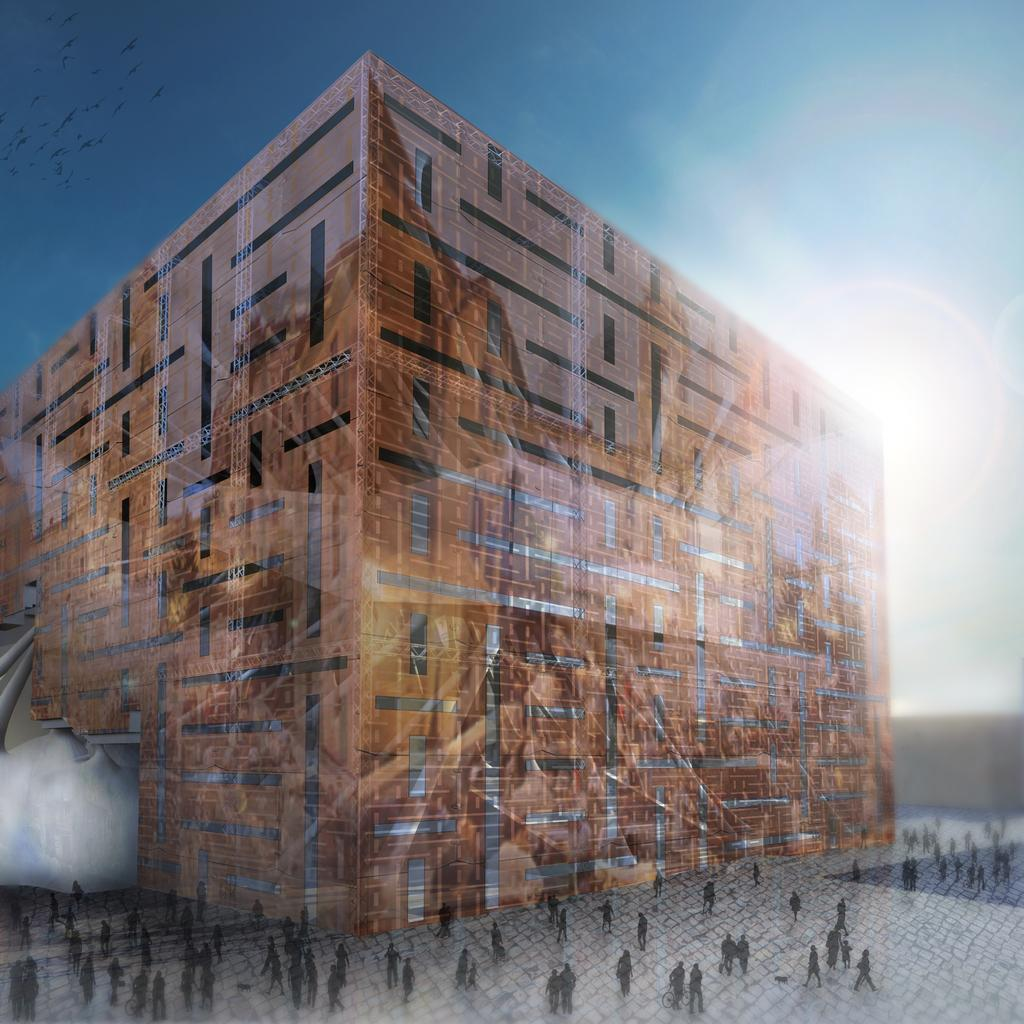How has the image been altered? The image is edited. What is the main focus of the image? There is a building in the center of the picture. Can you describe the people in the foreground? There are people in the foreground. What is the weather like in the image? The sky is clear, and it is sunny. What else can be seen in the image? There are birds at the top left of the image. What time of day is the heart beating in the image? There is no heart present in the image, so it is not possible to determine when a heart might be beating. 